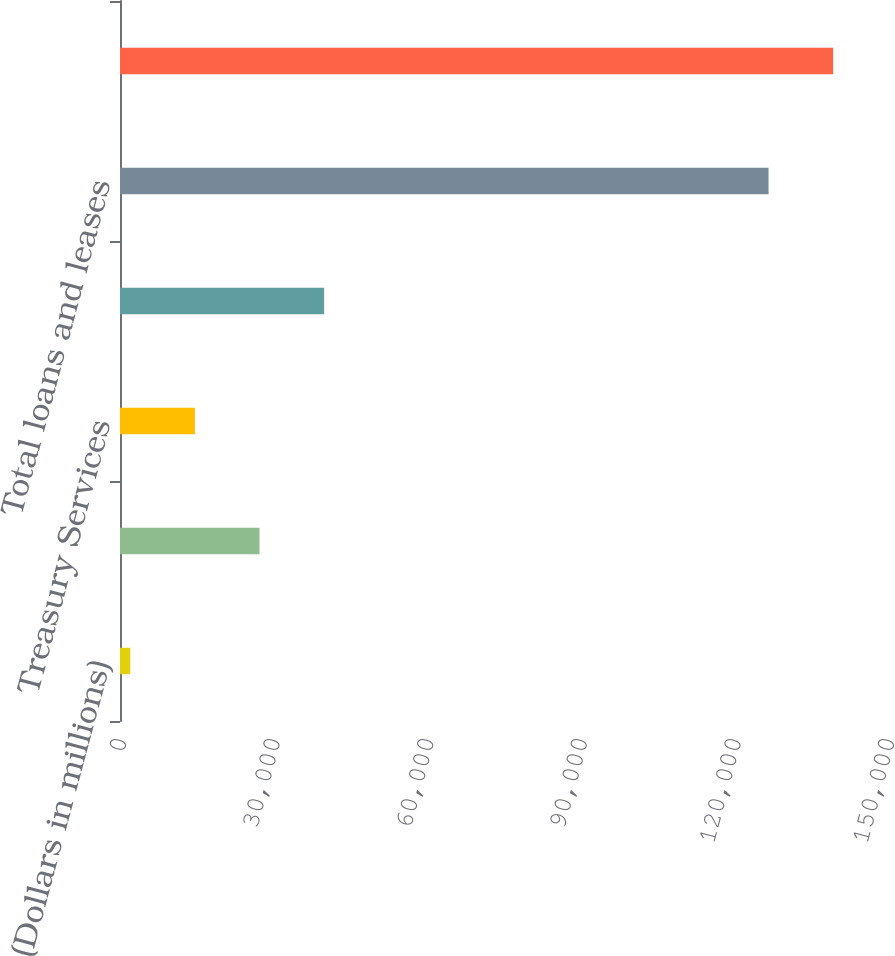Convert chart to OTSL. <chart><loc_0><loc_0><loc_500><loc_500><bar_chart><fcel>(Dollars in millions)<fcel>Business Lending<fcel>Treasury Services<fcel>Total revenue net of interest<fcel>Total loans and leases<fcel>Total deposits<nl><fcel>2013<fcel>27250<fcel>14631.5<fcel>39868.5<fcel>126669<fcel>139288<nl></chart> 